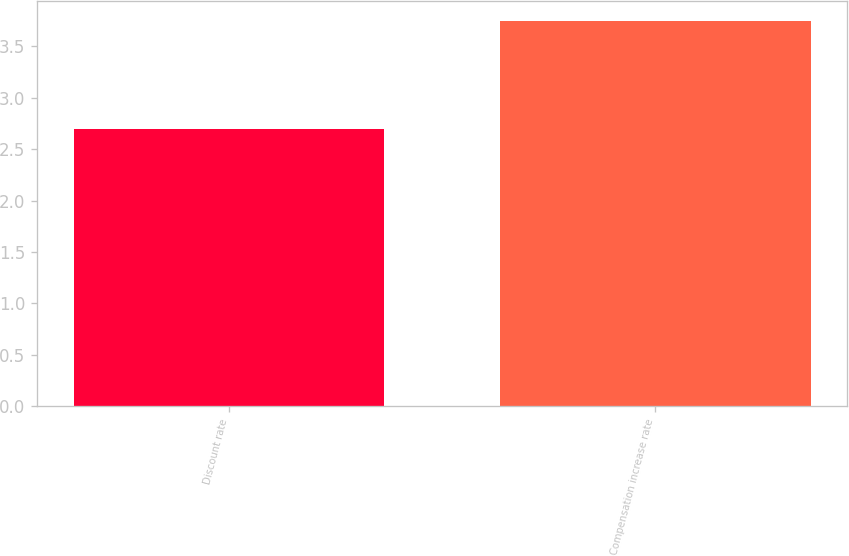Convert chart. <chart><loc_0><loc_0><loc_500><loc_500><bar_chart><fcel>Discount rate<fcel>Compensation increase rate<nl><fcel>2.7<fcel>3.75<nl></chart> 